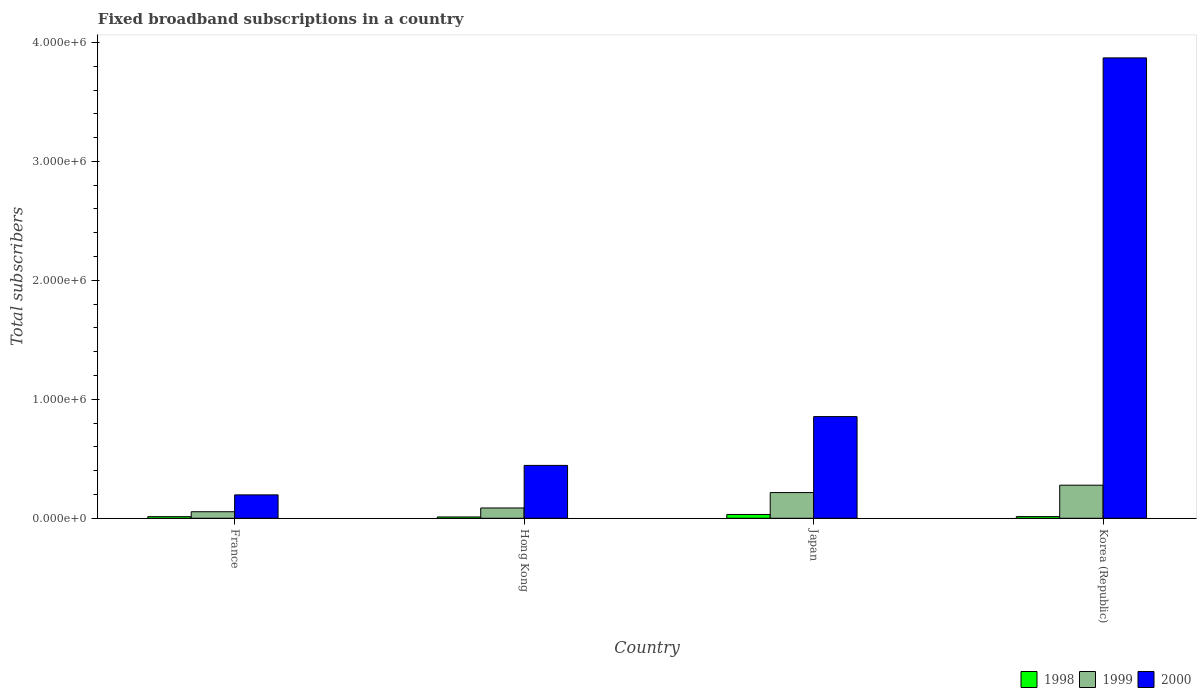How many different coloured bars are there?
Ensure brevity in your answer.  3. How many groups of bars are there?
Ensure brevity in your answer.  4. Are the number of bars per tick equal to the number of legend labels?
Your answer should be very brief. Yes. Are the number of bars on each tick of the X-axis equal?
Give a very brief answer. Yes. How many bars are there on the 1st tick from the right?
Provide a succinct answer. 3. What is the label of the 1st group of bars from the left?
Keep it short and to the point. France. What is the number of broadband subscriptions in 1998 in France?
Offer a very short reply. 1.35e+04. Across all countries, what is the maximum number of broadband subscriptions in 2000?
Your answer should be compact. 3.87e+06. Across all countries, what is the minimum number of broadband subscriptions in 2000?
Keep it short and to the point. 1.97e+05. In which country was the number of broadband subscriptions in 2000 maximum?
Your answer should be very brief. Korea (Republic). In which country was the number of broadband subscriptions in 1999 minimum?
Your answer should be compact. France. What is the total number of broadband subscriptions in 1999 in the graph?
Offer a very short reply. 6.35e+05. What is the difference between the number of broadband subscriptions in 1998 in France and that in Korea (Republic)?
Make the answer very short. -536. What is the difference between the number of broadband subscriptions in 1998 in France and the number of broadband subscriptions in 2000 in Japan?
Give a very brief answer. -8.41e+05. What is the average number of broadband subscriptions in 1998 per country?
Your answer should be very brief. 1.76e+04. What is the difference between the number of broadband subscriptions of/in 1999 and number of broadband subscriptions of/in 2000 in Japan?
Give a very brief answer. -6.39e+05. In how many countries, is the number of broadband subscriptions in 2000 greater than 2800000?
Ensure brevity in your answer.  1. What is the ratio of the number of broadband subscriptions in 1998 in Hong Kong to that in Korea (Republic)?
Provide a succinct answer. 0.79. What is the difference between the highest and the second highest number of broadband subscriptions in 1999?
Offer a very short reply. 1.92e+05. What is the difference between the highest and the lowest number of broadband subscriptions in 1998?
Your response must be concise. 2.10e+04. In how many countries, is the number of broadband subscriptions in 1998 greater than the average number of broadband subscriptions in 1998 taken over all countries?
Your response must be concise. 1. What does the 3rd bar from the right in Japan represents?
Give a very brief answer. 1998. Is it the case that in every country, the sum of the number of broadband subscriptions in 2000 and number of broadband subscriptions in 1999 is greater than the number of broadband subscriptions in 1998?
Offer a terse response. Yes. What is the difference between two consecutive major ticks on the Y-axis?
Your answer should be very brief. 1.00e+06. Are the values on the major ticks of Y-axis written in scientific E-notation?
Your answer should be compact. Yes. Does the graph contain any zero values?
Offer a terse response. No. Does the graph contain grids?
Your answer should be very brief. No. Where does the legend appear in the graph?
Your answer should be compact. Bottom right. How are the legend labels stacked?
Your response must be concise. Horizontal. What is the title of the graph?
Ensure brevity in your answer.  Fixed broadband subscriptions in a country. Does "1966" appear as one of the legend labels in the graph?
Keep it short and to the point. No. What is the label or title of the Y-axis?
Your answer should be compact. Total subscribers. What is the Total subscribers of 1998 in France?
Provide a short and direct response. 1.35e+04. What is the Total subscribers of 1999 in France?
Make the answer very short. 5.50e+04. What is the Total subscribers in 2000 in France?
Keep it short and to the point. 1.97e+05. What is the Total subscribers of 1998 in Hong Kong?
Make the answer very short. 1.10e+04. What is the Total subscribers in 1999 in Hong Kong?
Offer a terse response. 8.65e+04. What is the Total subscribers of 2000 in Hong Kong?
Your answer should be compact. 4.44e+05. What is the Total subscribers of 1998 in Japan?
Offer a very short reply. 3.20e+04. What is the Total subscribers of 1999 in Japan?
Your answer should be compact. 2.16e+05. What is the Total subscribers in 2000 in Japan?
Ensure brevity in your answer.  8.55e+05. What is the Total subscribers of 1998 in Korea (Republic)?
Provide a short and direct response. 1.40e+04. What is the Total subscribers in 1999 in Korea (Republic)?
Make the answer very short. 2.78e+05. What is the Total subscribers in 2000 in Korea (Republic)?
Provide a succinct answer. 3.87e+06. Across all countries, what is the maximum Total subscribers in 1998?
Offer a terse response. 3.20e+04. Across all countries, what is the maximum Total subscribers in 1999?
Your answer should be compact. 2.78e+05. Across all countries, what is the maximum Total subscribers of 2000?
Your response must be concise. 3.87e+06. Across all countries, what is the minimum Total subscribers of 1998?
Keep it short and to the point. 1.10e+04. Across all countries, what is the minimum Total subscribers in 1999?
Your answer should be compact. 5.50e+04. Across all countries, what is the minimum Total subscribers of 2000?
Provide a short and direct response. 1.97e+05. What is the total Total subscribers in 1998 in the graph?
Provide a short and direct response. 7.05e+04. What is the total Total subscribers in 1999 in the graph?
Offer a terse response. 6.35e+05. What is the total Total subscribers in 2000 in the graph?
Provide a short and direct response. 5.37e+06. What is the difference between the Total subscribers of 1998 in France and that in Hong Kong?
Provide a succinct answer. 2464. What is the difference between the Total subscribers in 1999 in France and that in Hong Kong?
Offer a very short reply. -3.15e+04. What is the difference between the Total subscribers in 2000 in France and that in Hong Kong?
Your answer should be compact. -2.48e+05. What is the difference between the Total subscribers in 1998 in France and that in Japan?
Your answer should be very brief. -1.85e+04. What is the difference between the Total subscribers of 1999 in France and that in Japan?
Provide a succinct answer. -1.61e+05. What is the difference between the Total subscribers of 2000 in France and that in Japan?
Your response must be concise. -6.58e+05. What is the difference between the Total subscribers in 1998 in France and that in Korea (Republic)?
Make the answer very short. -536. What is the difference between the Total subscribers of 1999 in France and that in Korea (Republic)?
Your answer should be compact. -2.23e+05. What is the difference between the Total subscribers of 2000 in France and that in Korea (Republic)?
Your response must be concise. -3.67e+06. What is the difference between the Total subscribers of 1998 in Hong Kong and that in Japan?
Keep it short and to the point. -2.10e+04. What is the difference between the Total subscribers in 1999 in Hong Kong and that in Japan?
Ensure brevity in your answer.  -1.30e+05. What is the difference between the Total subscribers in 2000 in Hong Kong and that in Japan?
Keep it short and to the point. -4.10e+05. What is the difference between the Total subscribers of 1998 in Hong Kong and that in Korea (Republic)?
Keep it short and to the point. -3000. What is the difference between the Total subscribers in 1999 in Hong Kong and that in Korea (Republic)?
Keep it short and to the point. -1.92e+05. What is the difference between the Total subscribers of 2000 in Hong Kong and that in Korea (Republic)?
Offer a terse response. -3.43e+06. What is the difference between the Total subscribers in 1998 in Japan and that in Korea (Republic)?
Make the answer very short. 1.80e+04. What is the difference between the Total subscribers of 1999 in Japan and that in Korea (Republic)?
Keep it short and to the point. -6.20e+04. What is the difference between the Total subscribers in 2000 in Japan and that in Korea (Republic)?
Your answer should be compact. -3.02e+06. What is the difference between the Total subscribers in 1998 in France and the Total subscribers in 1999 in Hong Kong?
Your answer should be very brief. -7.30e+04. What is the difference between the Total subscribers in 1998 in France and the Total subscribers in 2000 in Hong Kong?
Keep it short and to the point. -4.31e+05. What is the difference between the Total subscribers of 1999 in France and the Total subscribers of 2000 in Hong Kong?
Your response must be concise. -3.89e+05. What is the difference between the Total subscribers in 1998 in France and the Total subscribers in 1999 in Japan?
Ensure brevity in your answer.  -2.03e+05. What is the difference between the Total subscribers in 1998 in France and the Total subscribers in 2000 in Japan?
Give a very brief answer. -8.41e+05. What is the difference between the Total subscribers in 1999 in France and the Total subscribers in 2000 in Japan?
Give a very brief answer. -8.00e+05. What is the difference between the Total subscribers of 1998 in France and the Total subscribers of 1999 in Korea (Republic)?
Your answer should be compact. -2.65e+05. What is the difference between the Total subscribers in 1998 in France and the Total subscribers in 2000 in Korea (Republic)?
Provide a short and direct response. -3.86e+06. What is the difference between the Total subscribers in 1999 in France and the Total subscribers in 2000 in Korea (Republic)?
Offer a very short reply. -3.82e+06. What is the difference between the Total subscribers in 1998 in Hong Kong and the Total subscribers in 1999 in Japan?
Offer a terse response. -2.05e+05. What is the difference between the Total subscribers in 1998 in Hong Kong and the Total subscribers in 2000 in Japan?
Your response must be concise. -8.44e+05. What is the difference between the Total subscribers of 1999 in Hong Kong and the Total subscribers of 2000 in Japan?
Provide a short and direct response. -7.68e+05. What is the difference between the Total subscribers in 1998 in Hong Kong and the Total subscribers in 1999 in Korea (Republic)?
Provide a short and direct response. -2.67e+05. What is the difference between the Total subscribers of 1998 in Hong Kong and the Total subscribers of 2000 in Korea (Republic)?
Offer a terse response. -3.86e+06. What is the difference between the Total subscribers in 1999 in Hong Kong and the Total subscribers in 2000 in Korea (Republic)?
Give a very brief answer. -3.78e+06. What is the difference between the Total subscribers in 1998 in Japan and the Total subscribers in 1999 in Korea (Republic)?
Make the answer very short. -2.46e+05. What is the difference between the Total subscribers of 1998 in Japan and the Total subscribers of 2000 in Korea (Republic)?
Your answer should be very brief. -3.84e+06. What is the difference between the Total subscribers of 1999 in Japan and the Total subscribers of 2000 in Korea (Republic)?
Give a very brief answer. -3.65e+06. What is the average Total subscribers in 1998 per country?
Make the answer very short. 1.76e+04. What is the average Total subscribers of 1999 per country?
Make the answer very short. 1.59e+05. What is the average Total subscribers in 2000 per country?
Offer a terse response. 1.34e+06. What is the difference between the Total subscribers of 1998 and Total subscribers of 1999 in France?
Ensure brevity in your answer.  -4.15e+04. What is the difference between the Total subscribers of 1998 and Total subscribers of 2000 in France?
Provide a succinct answer. -1.83e+05. What is the difference between the Total subscribers of 1999 and Total subscribers of 2000 in France?
Give a very brief answer. -1.42e+05. What is the difference between the Total subscribers in 1998 and Total subscribers in 1999 in Hong Kong?
Your response must be concise. -7.55e+04. What is the difference between the Total subscribers in 1998 and Total subscribers in 2000 in Hong Kong?
Keep it short and to the point. -4.33e+05. What is the difference between the Total subscribers in 1999 and Total subscribers in 2000 in Hong Kong?
Your answer should be very brief. -3.58e+05. What is the difference between the Total subscribers of 1998 and Total subscribers of 1999 in Japan?
Your response must be concise. -1.84e+05. What is the difference between the Total subscribers of 1998 and Total subscribers of 2000 in Japan?
Your answer should be compact. -8.23e+05. What is the difference between the Total subscribers of 1999 and Total subscribers of 2000 in Japan?
Keep it short and to the point. -6.39e+05. What is the difference between the Total subscribers in 1998 and Total subscribers in 1999 in Korea (Republic)?
Provide a short and direct response. -2.64e+05. What is the difference between the Total subscribers of 1998 and Total subscribers of 2000 in Korea (Republic)?
Make the answer very short. -3.86e+06. What is the difference between the Total subscribers in 1999 and Total subscribers in 2000 in Korea (Republic)?
Keep it short and to the point. -3.59e+06. What is the ratio of the Total subscribers of 1998 in France to that in Hong Kong?
Your answer should be compact. 1.22. What is the ratio of the Total subscribers of 1999 in France to that in Hong Kong?
Offer a terse response. 0.64. What is the ratio of the Total subscribers in 2000 in France to that in Hong Kong?
Provide a succinct answer. 0.44. What is the ratio of the Total subscribers in 1998 in France to that in Japan?
Your response must be concise. 0.42. What is the ratio of the Total subscribers in 1999 in France to that in Japan?
Your answer should be very brief. 0.25. What is the ratio of the Total subscribers in 2000 in France to that in Japan?
Your answer should be compact. 0.23. What is the ratio of the Total subscribers of 1998 in France to that in Korea (Republic)?
Give a very brief answer. 0.96. What is the ratio of the Total subscribers of 1999 in France to that in Korea (Republic)?
Offer a very short reply. 0.2. What is the ratio of the Total subscribers of 2000 in France to that in Korea (Republic)?
Ensure brevity in your answer.  0.05. What is the ratio of the Total subscribers in 1998 in Hong Kong to that in Japan?
Provide a succinct answer. 0.34. What is the ratio of the Total subscribers of 1999 in Hong Kong to that in Japan?
Keep it short and to the point. 0.4. What is the ratio of the Total subscribers of 2000 in Hong Kong to that in Japan?
Give a very brief answer. 0.52. What is the ratio of the Total subscribers of 1998 in Hong Kong to that in Korea (Republic)?
Provide a short and direct response. 0.79. What is the ratio of the Total subscribers of 1999 in Hong Kong to that in Korea (Republic)?
Give a very brief answer. 0.31. What is the ratio of the Total subscribers of 2000 in Hong Kong to that in Korea (Republic)?
Make the answer very short. 0.11. What is the ratio of the Total subscribers of 1998 in Japan to that in Korea (Republic)?
Offer a terse response. 2.29. What is the ratio of the Total subscribers of 1999 in Japan to that in Korea (Republic)?
Your answer should be very brief. 0.78. What is the ratio of the Total subscribers of 2000 in Japan to that in Korea (Republic)?
Keep it short and to the point. 0.22. What is the difference between the highest and the second highest Total subscribers of 1998?
Provide a succinct answer. 1.80e+04. What is the difference between the highest and the second highest Total subscribers of 1999?
Your answer should be very brief. 6.20e+04. What is the difference between the highest and the second highest Total subscribers in 2000?
Keep it short and to the point. 3.02e+06. What is the difference between the highest and the lowest Total subscribers in 1998?
Keep it short and to the point. 2.10e+04. What is the difference between the highest and the lowest Total subscribers of 1999?
Your answer should be compact. 2.23e+05. What is the difference between the highest and the lowest Total subscribers of 2000?
Provide a succinct answer. 3.67e+06. 